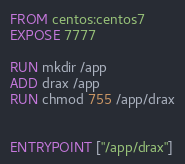Convert code to text. <code><loc_0><loc_0><loc_500><loc_500><_Dockerfile_>FROM centos:centos7
EXPOSE 7777

RUN mkdir /app
ADD drax /app
RUN chmod 755 /app/drax


ENTRYPOINT ["/app/drax"]
</code> 